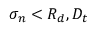<formula> <loc_0><loc_0><loc_500><loc_500>\sigma _ { n } < R _ { d } , D _ { t }</formula> 